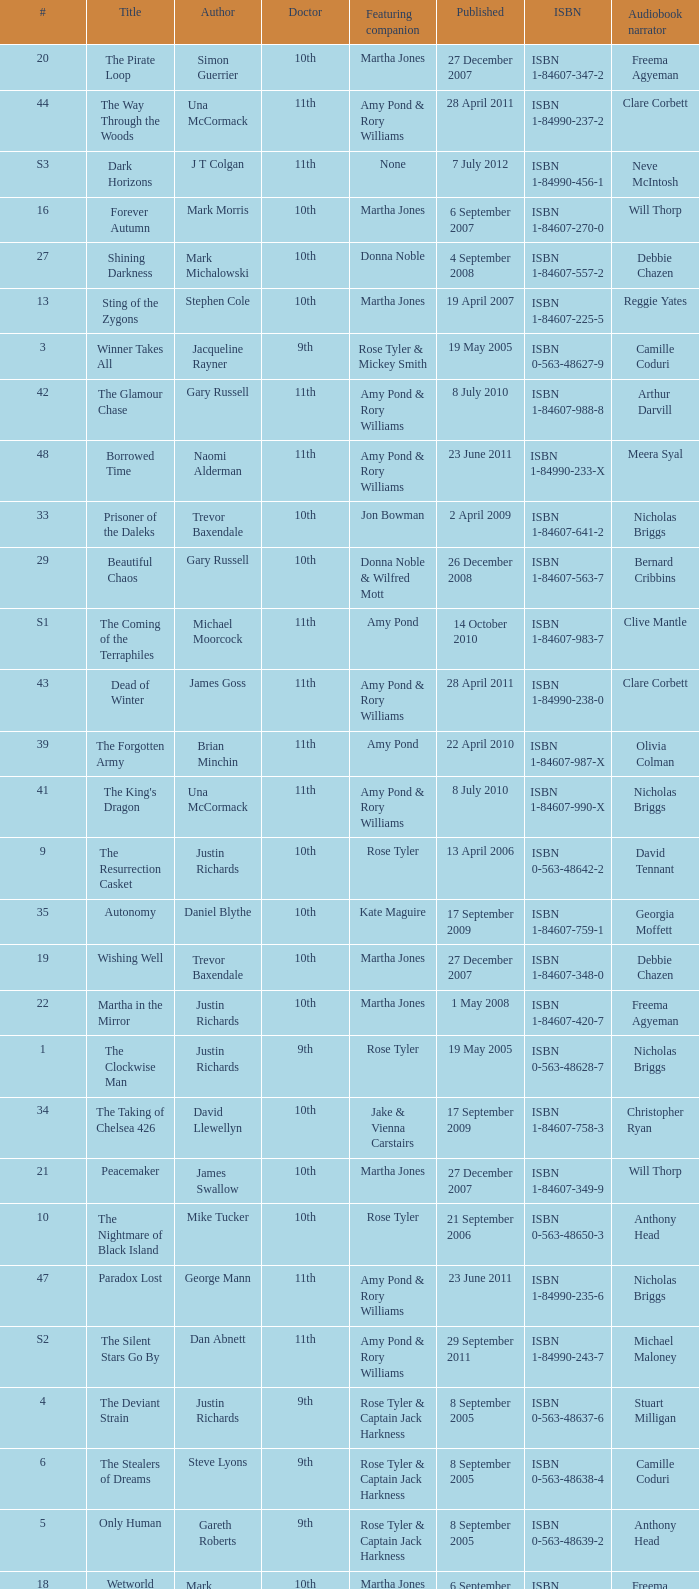What is the title of book number 8? The Feast of the Drowned. 